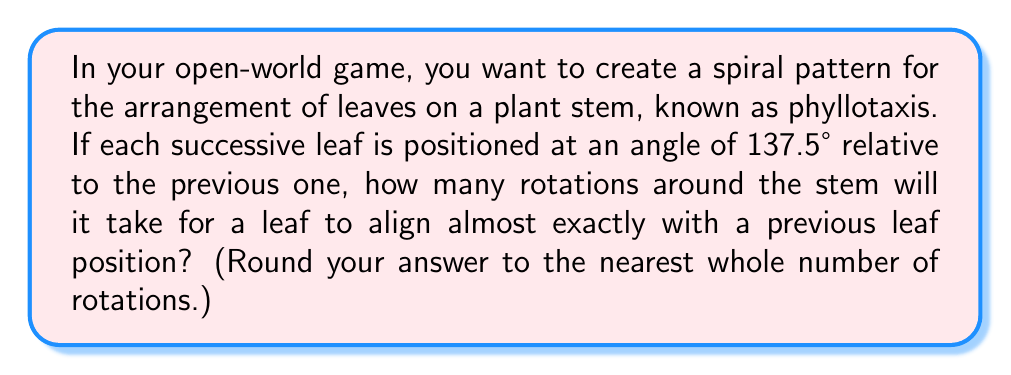Could you help me with this problem? Let's approach this step-by-step:

1) The angle between successive leaves is 137.5°. This is known as the golden angle in nature.

2) For a leaf to align almost exactly with a previous position, we need to find how many times we need to rotate by 137.5° to get close to a multiple of 360° (a full rotation).

3) Mathematically, we're looking for an integer $n$ such that:

   $n \times 137.5° \approx k \times 360°$

   where $k$ is also an integer.

4) Let's divide both sides by 360°:

   $\frac{n \times 137.5°}{360°} \approx k$

5) Simplifying:

   $n \times \frac{137.5}{360} \approx k$

6) $\frac{137.5}{360} \approx 0.3819444...$

7) This is very close to $\frac{13}{34} \approx 0.3823529...$

8) Therefore, after 34 rotations of 137.5°, we'll be very close to 13 full rotations:

   $34 \times 137.5° = 4675° = 12.9861... \times 360°$

9) This means after 34 leaves, the 35th leaf will be almost perfectly aligned with the 1st leaf.
Answer: 34 rotations 